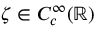Convert formula to latex. <formula><loc_0><loc_0><loc_500><loc_500>\zeta \in C _ { c } ^ { \infty } ( { \mathbb { R } } )</formula> 